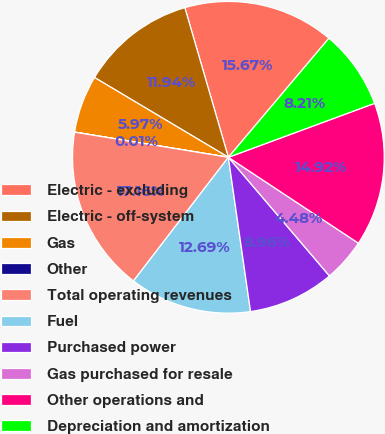Convert chart. <chart><loc_0><loc_0><loc_500><loc_500><pie_chart><fcel>Electric - excluding<fcel>Electric - off-system<fcel>Gas<fcel>Other<fcel>Total operating revenues<fcel>Fuel<fcel>Purchased power<fcel>Gas purchased for resale<fcel>Other operations and<fcel>Depreciation and amortization<nl><fcel>15.67%<fcel>11.94%<fcel>5.97%<fcel>0.01%<fcel>17.16%<fcel>12.69%<fcel>8.96%<fcel>4.48%<fcel>14.92%<fcel>8.21%<nl></chart> 